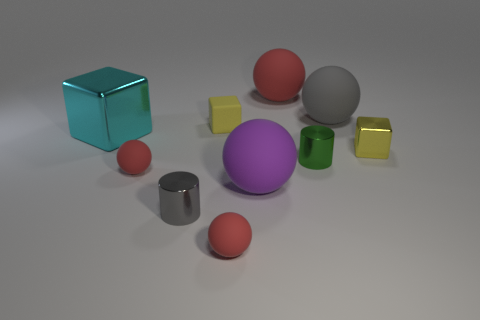Is the number of big gray spheres greater than the number of metallic objects?
Give a very brief answer. No. Is there a tiny gray shiny cylinder that is on the right side of the cylinder to the right of the gray object left of the gray matte object?
Offer a terse response. No. How many other objects are the same size as the rubber cube?
Make the answer very short. 5. There is a small yellow shiny thing; are there any large red rubber things behind it?
Keep it short and to the point. Yes. Does the matte block have the same color as the small shiny cylinder right of the large purple object?
Your answer should be compact. No. The cylinder that is right of the yellow object behind the metallic cube right of the big purple matte thing is what color?
Provide a short and direct response. Green. Are there any small shiny things that have the same shape as the large purple thing?
Provide a short and direct response. No. What is the color of the metal cube that is the same size as the purple rubber ball?
Ensure brevity in your answer.  Cyan. There is a tiny yellow block on the right side of the small green metallic object; what is it made of?
Offer a terse response. Metal. There is a big purple thing that is on the left side of the green cylinder; does it have the same shape as the tiny yellow thing that is behind the cyan block?
Provide a succinct answer. No. 